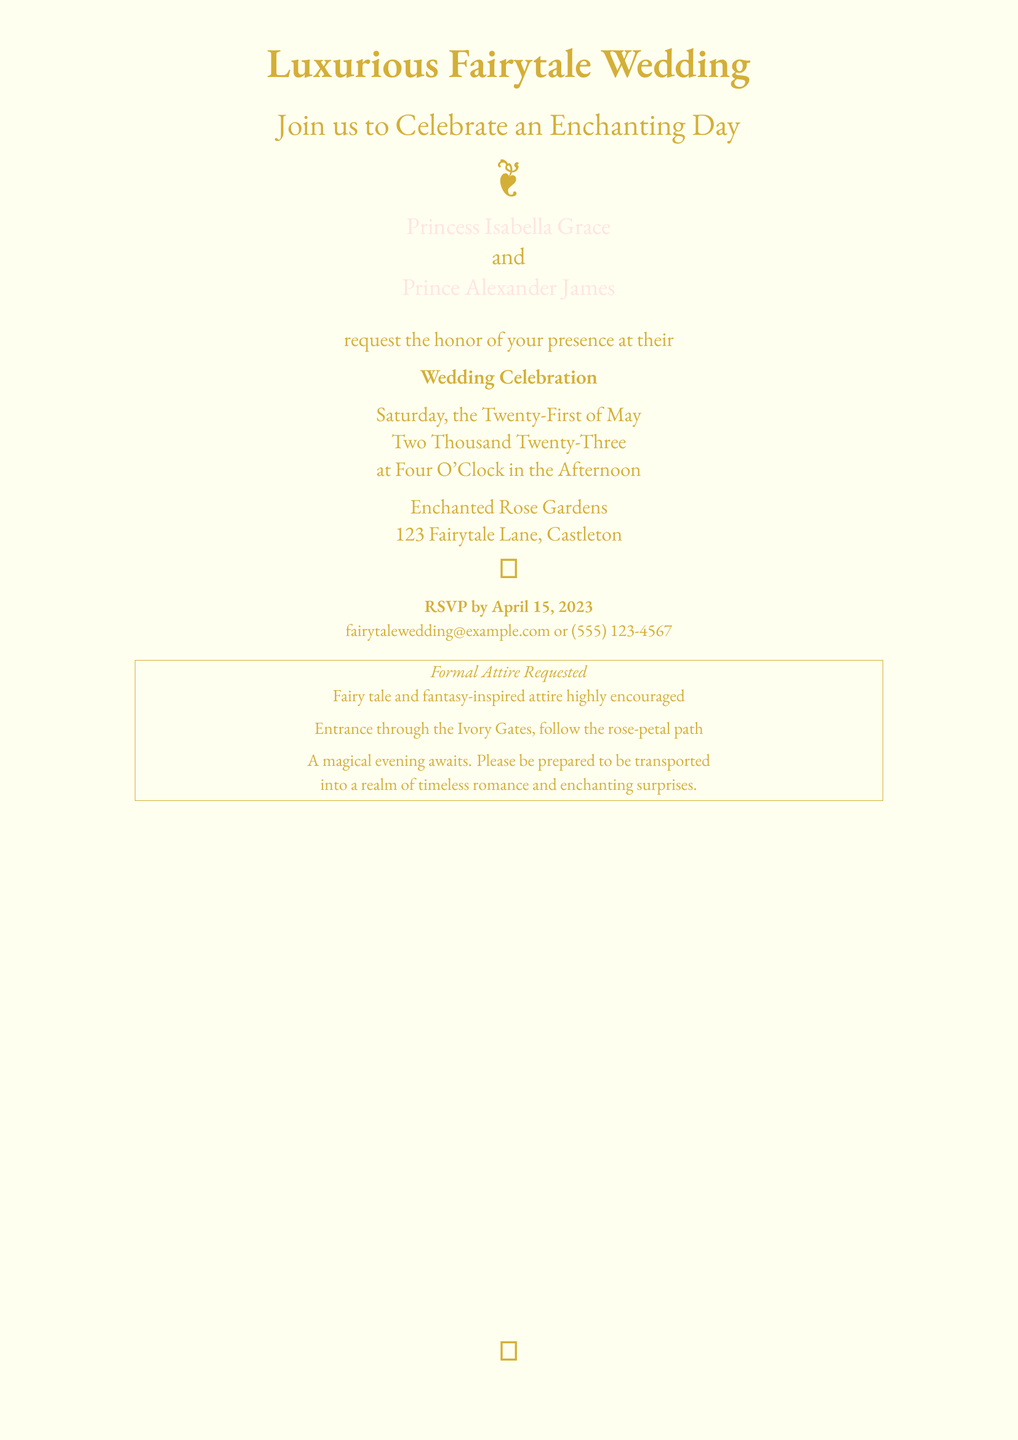What are the names of the couple? The names of the couple are specified in the invitation as "Princess Isabella Grace" and "Prince Alexander James".
Answer: Princess Isabella Grace and Prince Alexander James What is the date of the wedding? The wedding date is clearly stated in the document as "Saturday, the Twenty-First of May, Two Thousand Twenty-Three".
Answer: May 21, 2023 What is the venue of the wedding? The venue is indicated in the invitation as "Enchanted Rose Gardens".
Answer: Enchanted Rose Gardens What time does the wedding start? The invitation specifies the time of the wedding as "Four O'Clock in the Afternoon".
Answer: Four O'Clock in the Afternoon What attire is requested for the guests? The invitation asks for "Formal Attire" and mentions a preference for "Fairy tale and fantasy-inspired attire".
Answer: Formal Attire What is the RSVP deadline? The document mentions the RSVP deadline as "April 15, 2023".
Answer: April 15, 2023 What kind of experience does the invitation promise? The invitation describes the event as a magical and enchanting experience.
Answer: Magical evening How does the invitation suggest guests enter the venue? The invitation instructs guests to enter through "the Ivory Gates" and follow "the rose-petal path".
Answer: Ivory Gates, rose-petal path 